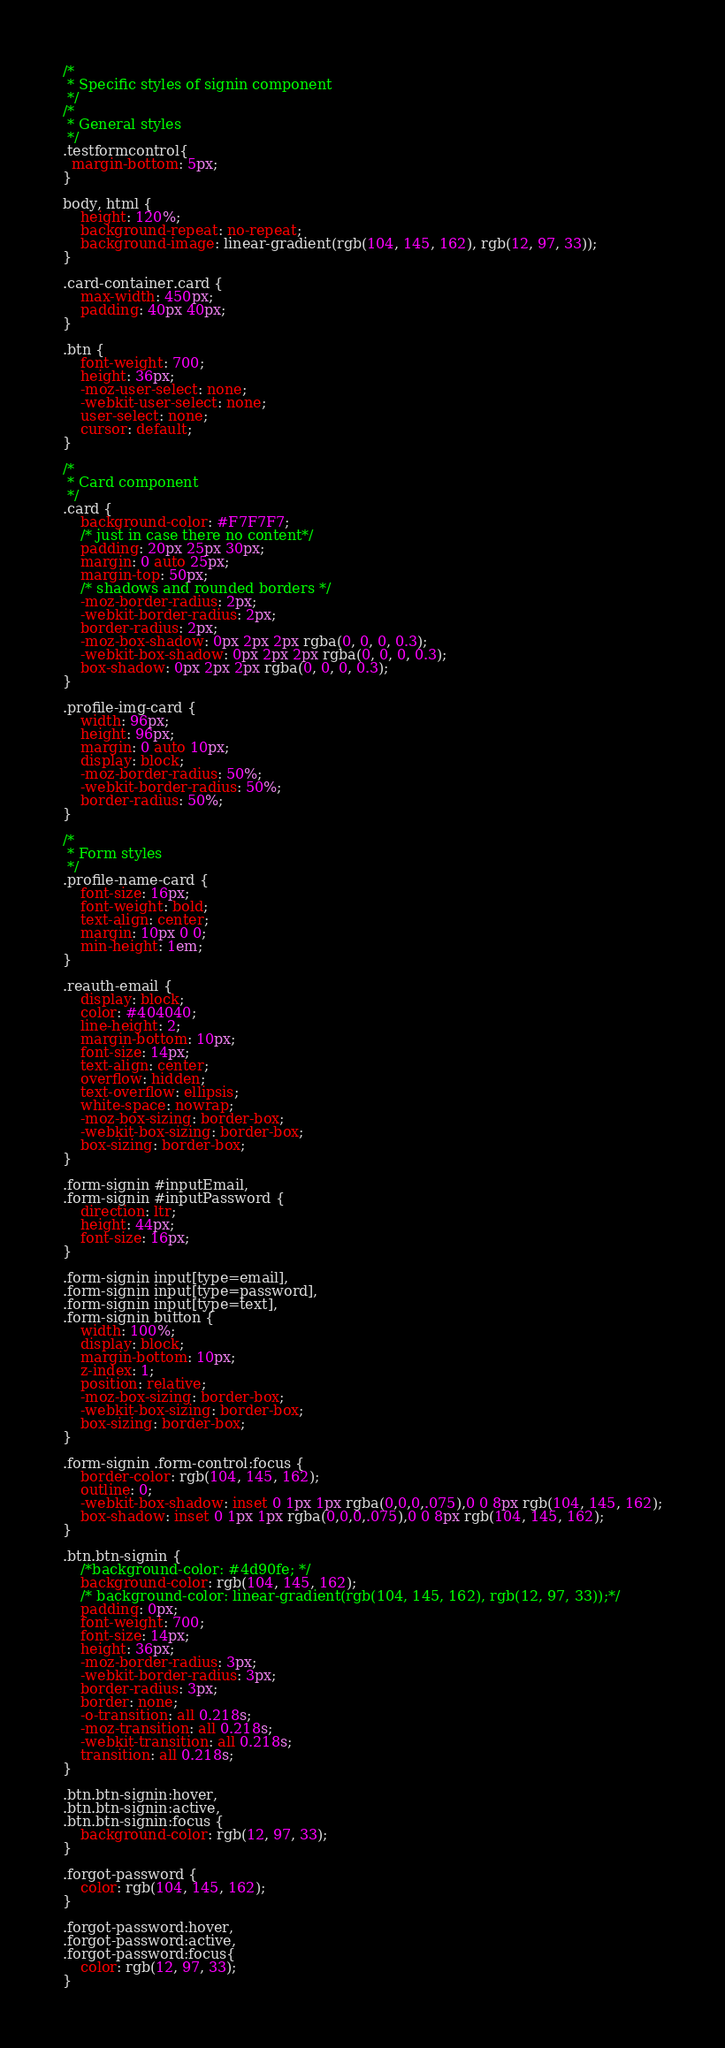<code> <loc_0><loc_0><loc_500><loc_500><_CSS_>/*
 * Specific styles of signin component
 */
/*
 * General styles
 */
.testformcontrol{
  margin-bottom: 5px;
}

body, html {
    height: 120%;
    background-repeat: no-repeat;
    background-image: linear-gradient(rgb(104, 145, 162), rgb(12, 97, 33));
}

.card-container.card {
    max-width: 450px;
    padding: 40px 40px;
}

.btn {
    font-weight: 700;
    height: 36px;
    -moz-user-select: none;
    -webkit-user-select: none;
    user-select: none;
    cursor: default;
}

/*
 * Card component
 */
.card {
    background-color: #F7F7F7;
    /* just in case there no content*/
    padding: 20px 25px 30px;
    margin: 0 auto 25px;
    margin-top: 50px;
    /* shadows and rounded borders */
    -moz-border-radius: 2px;
    -webkit-border-radius: 2px;
    border-radius: 2px;
    -moz-box-shadow: 0px 2px 2px rgba(0, 0, 0, 0.3);
    -webkit-box-shadow: 0px 2px 2px rgba(0, 0, 0, 0.3);
    box-shadow: 0px 2px 2px rgba(0, 0, 0, 0.3);
}

.profile-img-card {
    width: 96px;
    height: 96px;
    margin: 0 auto 10px;
    display: block;
    -moz-border-radius: 50%;
    -webkit-border-radius: 50%;
    border-radius: 50%;
}

/*
 * Form styles
 */
.profile-name-card {
    font-size: 16px;
    font-weight: bold;
    text-align: center;
    margin: 10px 0 0;
    min-height: 1em;
}

.reauth-email {
    display: block;
    color: #404040;
    line-height: 2;
    margin-bottom: 10px;
    font-size: 14px;
    text-align: center;
    overflow: hidden;
    text-overflow: ellipsis;
    white-space: nowrap;
    -moz-box-sizing: border-box;
    -webkit-box-sizing: border-box;
    box-sizing: border-box;
}

.form-signin #inputEmail,
.form-signin #inputPassword {
    direction: ltr;
    height: 44px;
    font-size: 16px;
}

.form-signin input[type=email],
.form-signin input[type=password],
.form-signin input[type=text],
.form-signin button {
    width: 100%;
    display: block;
    margin-bottom: 10px;
    z-index: 1;
    position: relative;
    -moz-box-sizing: border-box;
    -webkit-box-sizing: border-box;
    box-sizing: border-box;
}

.form-signin .form-control:focus {
    border-color: rgb(104, 145, 162);
    outline: 0;
    -webkit-box-shadow: inset 0 1px 1px rgba(0,0,0,.075),0 0 8px rgb(104, 145, 162);
    box-shadow: inset 0 1px 1px rgba(0,0,0,.075),0 0 8px rgb(104, 145, 162);
}

.btn.btn-signin {
    /*background-color: #4d90fe; */
    background-color: rgb(104, 145, 162);
    /* background-color: linear-gradient(rgb(104, 145, 162), rgb(12, 97, 33));*/
    padding: 0px;
    font-weight: 700;
    font-size: 14px;
    height: 36px;
    -moz-border-radius: 3px;
    -webkit-border-radius: 3px;
    border-radius: 3px;
    border: none;
    -o-transition: all 0.218s;
    -moz-transition: all 0.218s;
    -webkit-transition: all 0.218s;
    transition: all 0.218s;
}

.btn.btn-signin:hover,
.btn.btn-signin:active,
.btn.btn-signin:focus {
    background-color: rgb(12, 97, 33);
}

.forgot-password {
    color: rgb(104, 145, 162);
}

.forgot-password:hover,
.forgot-password:active,
.forgot-password:focus{
    color: rgb(12, 97, 33);
}
</code> 